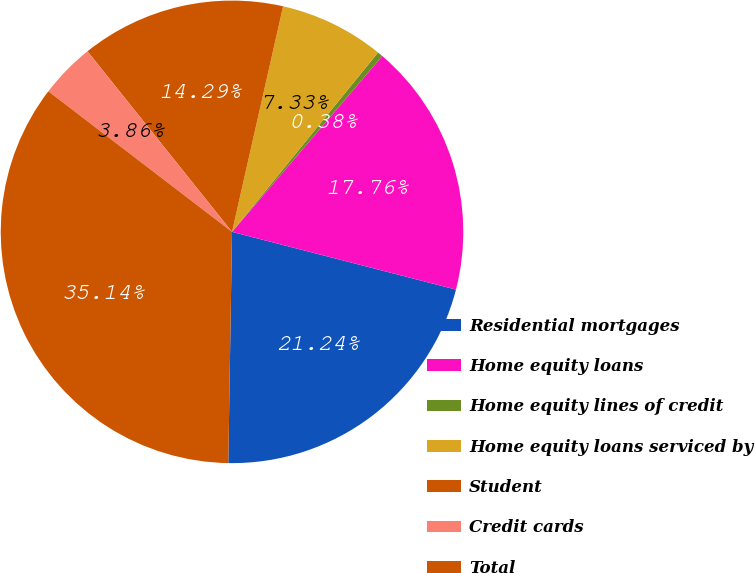Convert chart. <chart><loc_0><loc_0><loc_500><loc_500><pie_chart><fcel>Residential mortgages<fcel>Home equity loans<fcel>Home equity lines of credit<fcel>Home equity loans serviced by<fcel>Student<fcel>Credit cards<fcel>Total<nl><fcel>21.24%<fcel>17.76%<fcel>0.38%<fcel>7.33%<fcel>14.29%<fcel>3.86%<fcel>35.14%<nl></chart> 